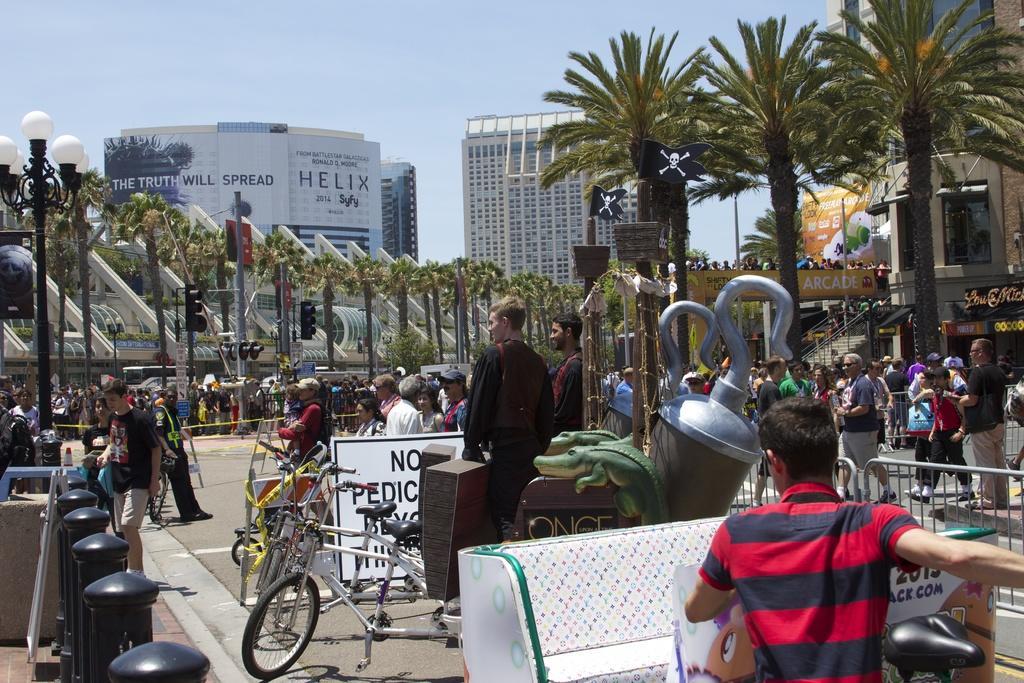Provide a one-sentence caption for the provided image. A busy street with an awning that says Arcade. 